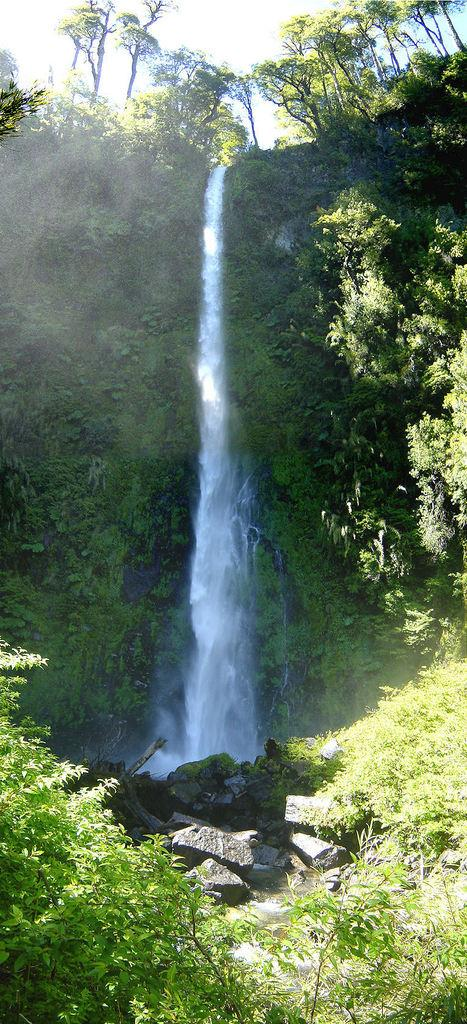What is the main feature in the center of the image? There is a waterfall in the center of the image. What can be found at the base of the waterfall? There are rocks at the bottom of the waterfall. What type of vegetation is visible in the image? Trees are visible in the image. What is visible at the top of the image? The sky is visible at the top of the image. What color is the chin of the person standing near the waterfall in the image? There is no person with a chin visible in the image; it features a waterfall, rocks, trees, and the sky. 